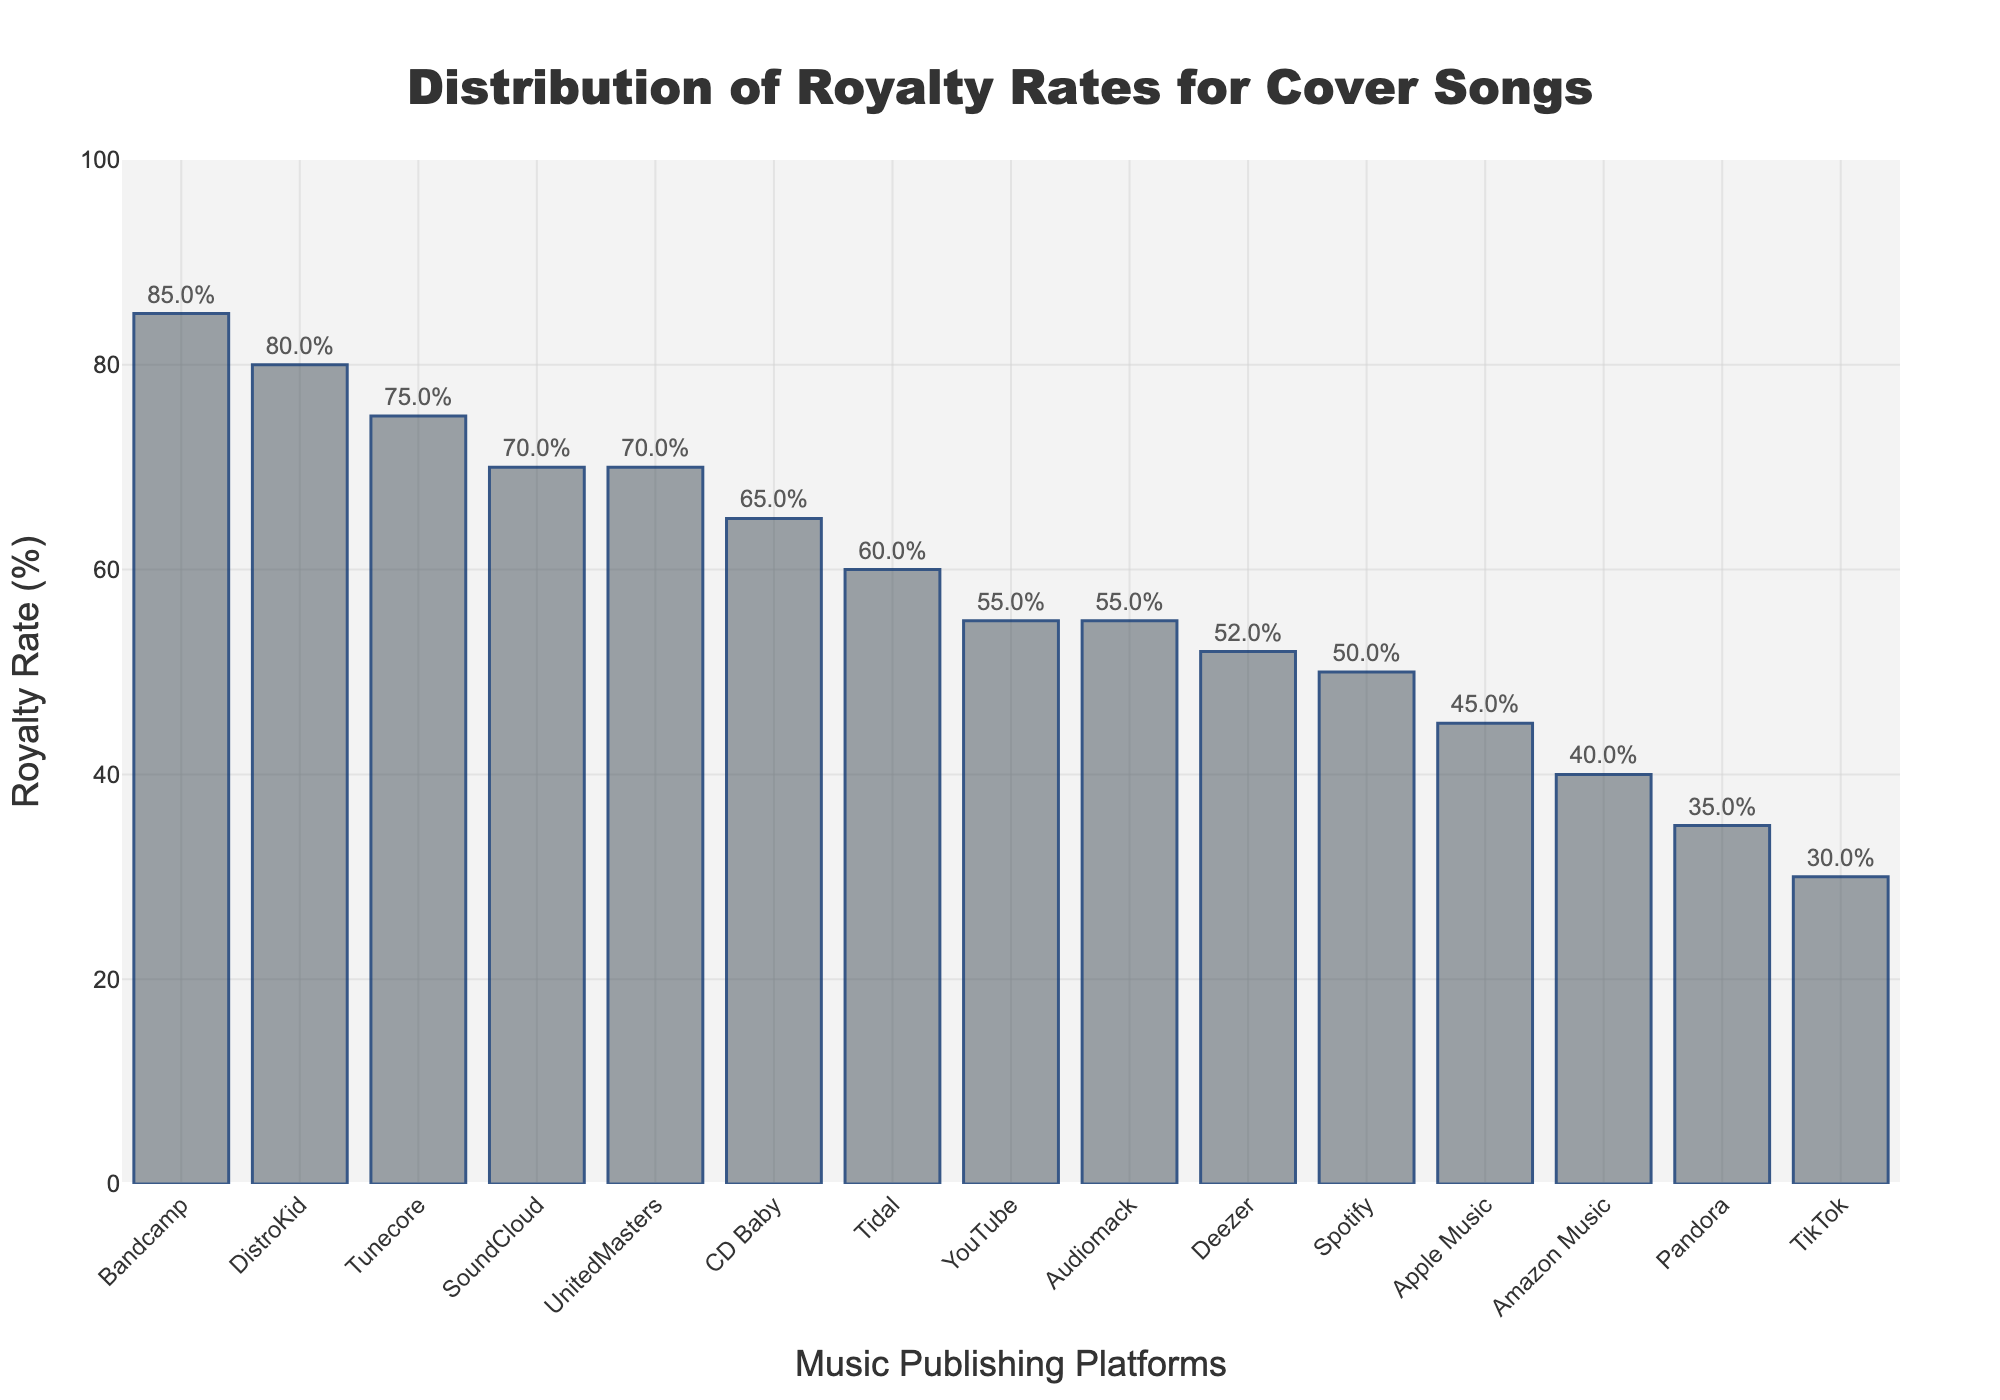Which platform has the highest royalty rate? The highest bar in the figure corresponds to the platform Bandcamp.
Answer: Bandcamp Which platforms have royalty rates greater than 60%? From the chart, the bars with heights greater than 60% correspond to Bandcamp, DistroKid, Tunecore, SoundCloud, UnitedMasters, and CD Baby.
Answer: Bandcamp, DistroKid, Tunecore, SoundCloud, UnitedMasters, CD Baby What is the difference in royalty rate between Spotify and Apple Music? The royalty rate for Spotify is 50%, and for Apple Music, it is 45%. The difference between them is 50% - 45% = 5%.
Answer: 5% What is the combined royalty rate of SoundCloud and UnitedMasters? The royalty rate for SoundCloud is 70%, and for UnitedMasters, it is 70%. Combined, it is 70% + 70% = 140%.
Answer: 140% How much higher is Bandcamp’s royalty rate compared to TikTok’s? Bandcamp’s royalty rate is 85%, and TikTok’s is 30%. The difference between them is 85% - 30% = 55%.
Answer: 55% Is DistroKid’s royalty rate greater than Tidal’s? Yes, DistroKid’s royalty rate is 80%, which is higher than Tidal’s 60%.
Answer: Yes What platforms have royalty rates between 50% and 70%? The bars that fall within the 50% to 70% range correspond to Spotify, YouTube, Deezer, Tidal, CD Baby, UnitedMasters, and Audiomack.
Answer: Spotify, YouTube, Deezer, Tidal, CD Baby, UnitedMasters, Audiomack What is the average royalty rate of the platforms in the figure? Sum the royalty rates of all platforms and divide by the number of platforms. (50 + 45 + 55 + 70 + 40 + 85 + 30 + 52 + 60 + 35 + 80 + 65 + 75 + 70 + 55) / 15 = 867 / 15 = 57.8%.
Answer: 57.8% Which platform has the lowest royalty rate? The lowest bar in the figure corresponds to the platform TikTok.
Answer: TikTok 